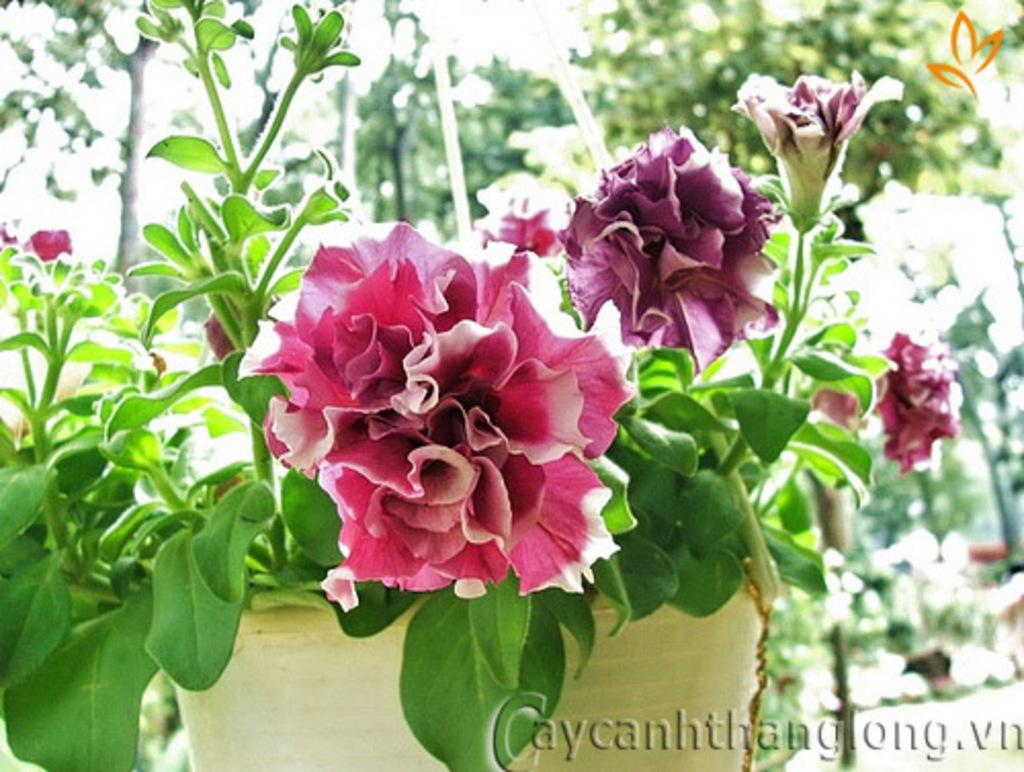What object is present in the foreground of the image? There is a flower pot in the image. What can be seen in the background of the image? There are trees in the background of the image. Is there any text or marking visible in the image? Yes, there is a watermark at the bottom of the image. How many pins are holding the sheet in place in the image? There is no sheet or pins present in the image. 